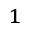Convert formula to latex. <formula><loc_0><loc_0><loc_500><loc_500>_ { 1 }</formula> 